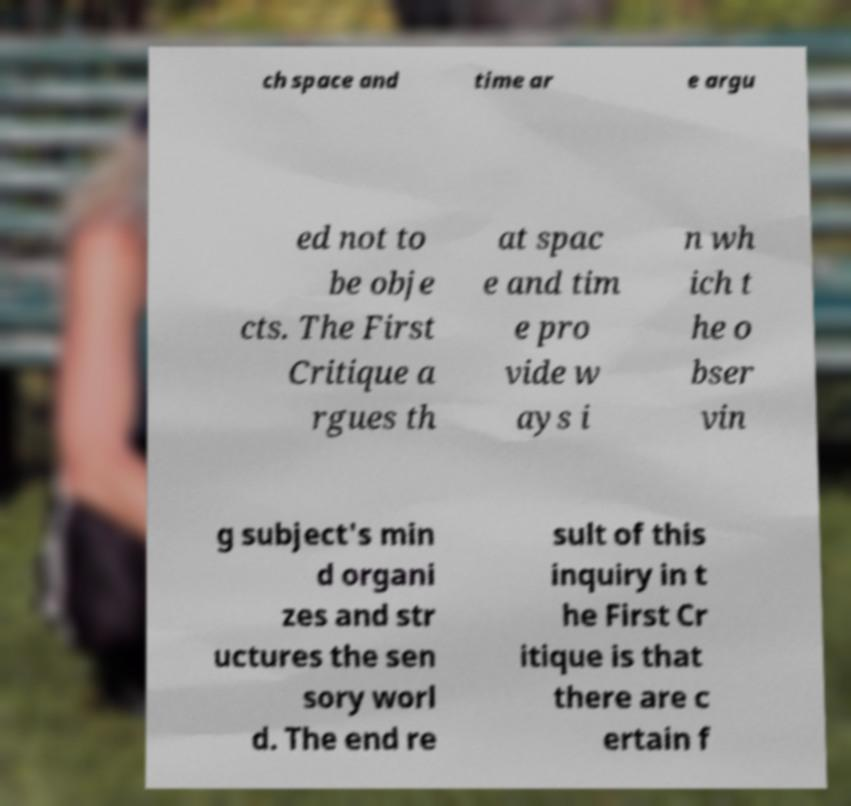Please identify and transcribe the text found in this image. ch space and time ar e argu ed not to be obje cts. The First Critique a rgues th at spac e and tim e pro vide w ays i n wh ich t he o bser vin g subject's min d organi zes and str uctures the sen sory worl d. The end re sult of this inquiry in t he First Cr itique is that there are c ertain f 